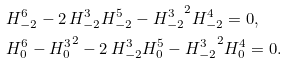Convert formula to latex. <formula><loc_0><loc_0><loc_500><loc_500>& H ^ { 6 } _ { - 2 } - 2 \, H ^ { 3 } _ { - 2 } H ^ { 5 } _ { - 2 } - { H ^ { 3 } _ { - 2 } } ^ { 2 } H ^ { 4 } _ { - 2 } = 0 , \\ & H ^ { 6 } _ { 0 } - { H ^ { 3 } _ { 0 } } ^ { 2 } - 2 \, H ^ { 3 } _ { - 2 } H ^ { 5 } _ { 0 } - { H ^ { 3 } _ { - 2 } } ^ { 2 } H ^ { 4 } _ { 0 } = 0 .</formula> 